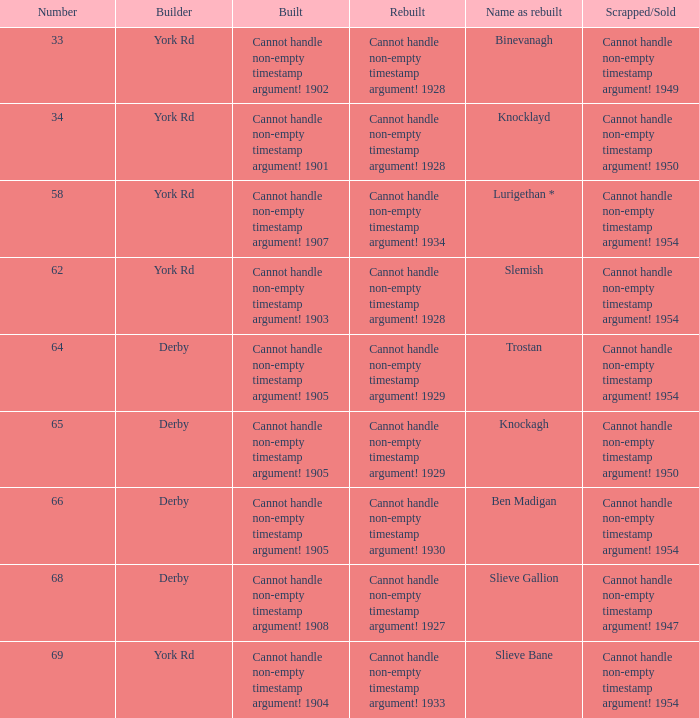Which Rebuilt has a Builder of derby, and a Name as rebuilt of ben madigan? Cannot handle non-empty timestamp argument! 1930. 